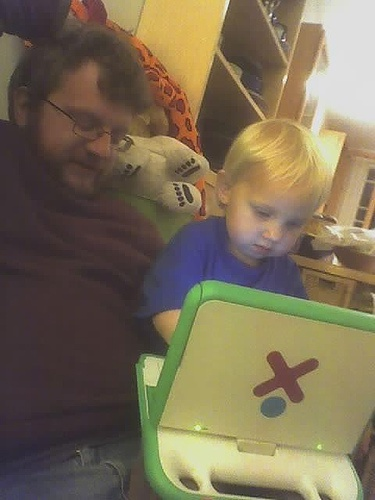Describe the objects in this image and their specific colors. I can see people in black, gray, and maroon tones, laptop in black, tan, khaki, green, and gray tones, people in black, purple, tan, and gray tones, and teddy bear in black, tan, and gray tones in this image. 